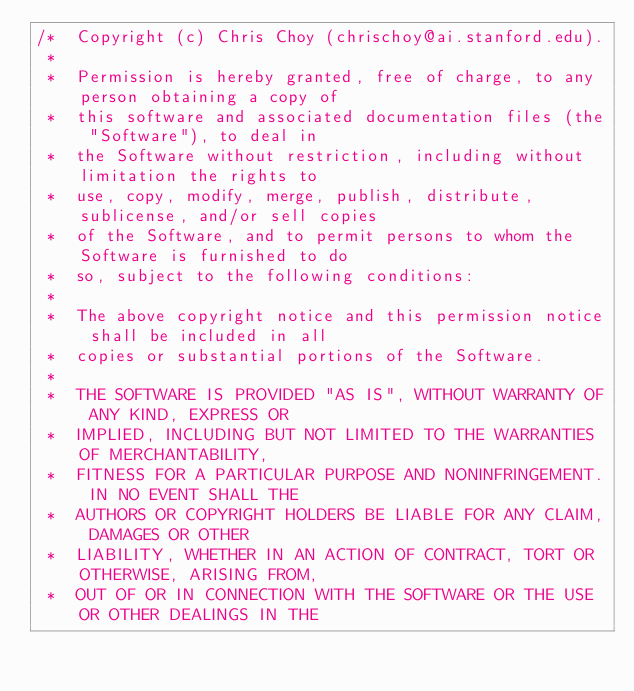Convert code to text. <code><loc_0><loc_0><loc_500><loc_500><_Cuda_>/*  Copyright (c) Chris Choy (chrischoy@ai.stanford.edu).
 *
 *  Permission is hereby granted, free of charge, to any person obtaining a copy of
 *  this software and associated documentation files (the "Software"), to deal in
 *  the Software without restriction, including without limitation the rights to
 *  use, copy, modify, merge, publish, distribute, sublicense, and/or sell copies
 *  of the Software, and to permit persons to whom the Software is furnished to do
 *  so, subject to the following conditions:
 *
 *  The above copyright notice and this permission notice shall be included in all
 *  copies or substantial portions of the Software.
 *
 *  THE SOFTWARE IS PROVIDED "AS IS", WITHOUT WARRANTY OF ANY KIND, EXPRESS OR
 *  IMPLIED, INCLUDING BUT NOT LIMITED TO THE WARRANTIES OF MERCHANTABILITY,
 *  FITNESS FOR A PARTICULAR PURPOSE AND NONINFRINGEMENT. IN NO EVENT SHALL THE
 *  AUTHORS OR COPYRIGHT HOLDERS BE LIABLE FOR ANY CLAIM, DAMAGES OR OTHER
 *  LIABILITY, WHETHER IN AN ACTION OF CONTRACT, TORT OR OTHERWISE, ARISING FROM,
 *  OUT OF OR IN CONNECTION WITH THE SOFTWARE OR THE USE OR OTHER DEALINGS IN THE</code> 